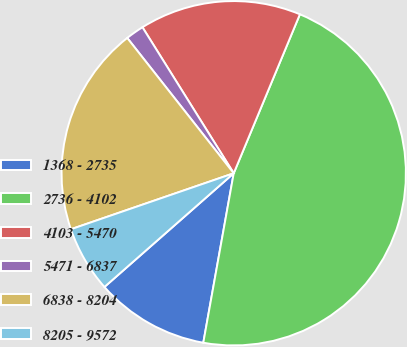Convert chart to OTSL. <chart><loc_0><loc_0><loc_500><loc_500><pie_chart><fcel>1368 - 2735<fcel>2736 - 4102<fcel>4103 - 5470<fcel>5471 - 6837<fcel>6838 - 8204<fcel>8205 - 9572<nl><fcel>10.69%<fcel>46.55%<fcel>15.17%<fcel>1.72%<fcel>19.66%<fcel>6.21%<nl></chart> 